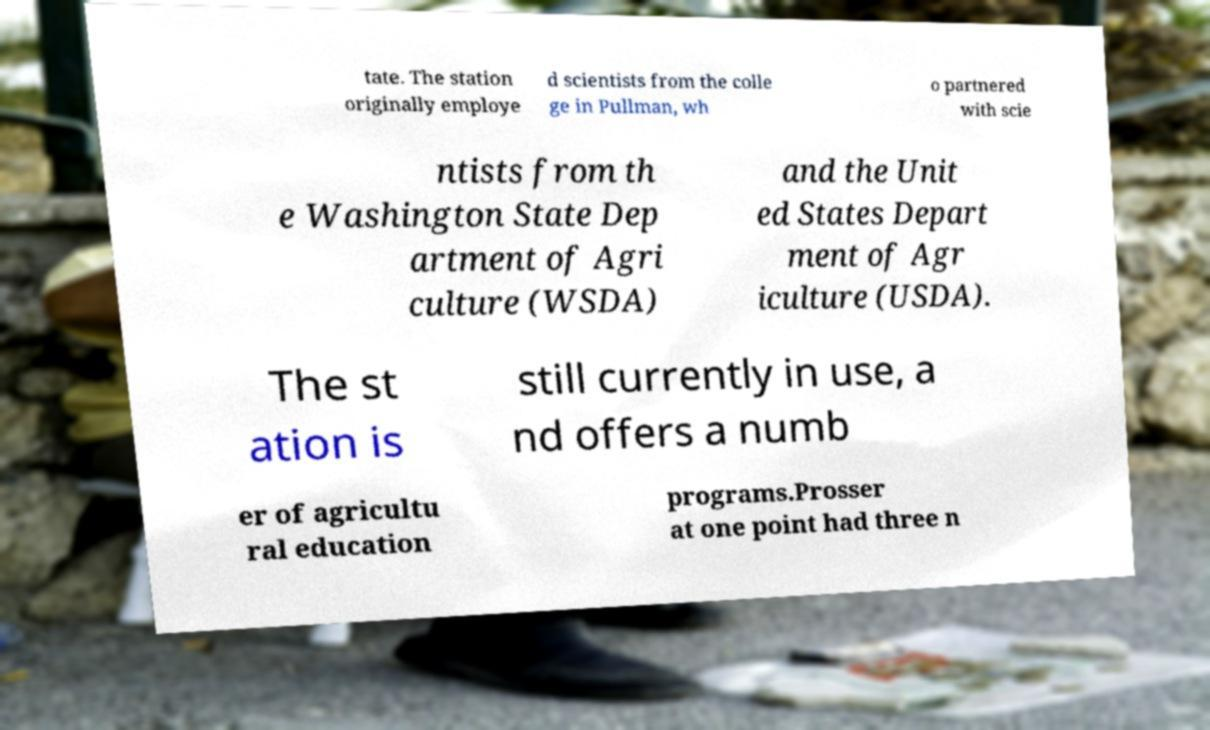Can you read and provide the text displayed in the image?This photo seems to have some interesting text. Can you extract and type it out for me? tate. The station originally employe d scientists from the colle ge in Pullman, wh o partnered with scie ntists from th e Washington State Dep artment of Agri culture (WSDA) and the Unit ed States Depart ment of Agr iculture (USDA). The st ation is still currently in use, a nd offers a numb er of agricultu ral education programs.Prosser at one point had three n 